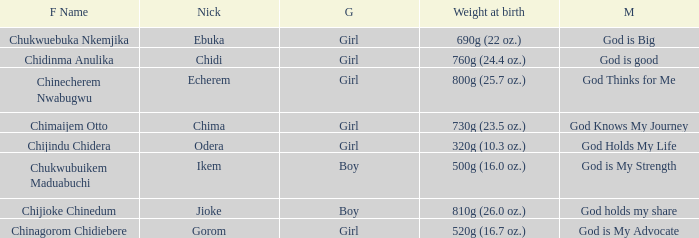What nickname has the meaning of God knows my journey? Chima. 